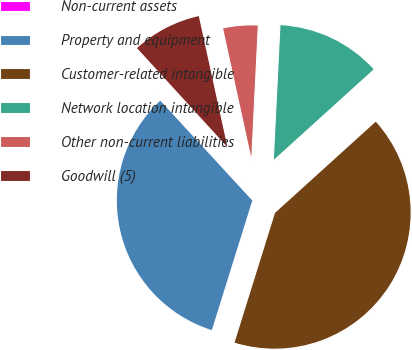<chart> <loc_0><loc_0><loc_500><loc_500><pie_chart><fcel>Non-current assets<fcel>Property and equipment<fcel>Customer-related intangible<fcel>Network location intangible<fcel>Other non-current liabilities<fcel>Goodwill (5)<nl><fcel>0.06%<fcel>33.34%<fcel>41.53%<fcel>12.5%<fcel>4.21%<fcel>8.36%<nl></chart> 